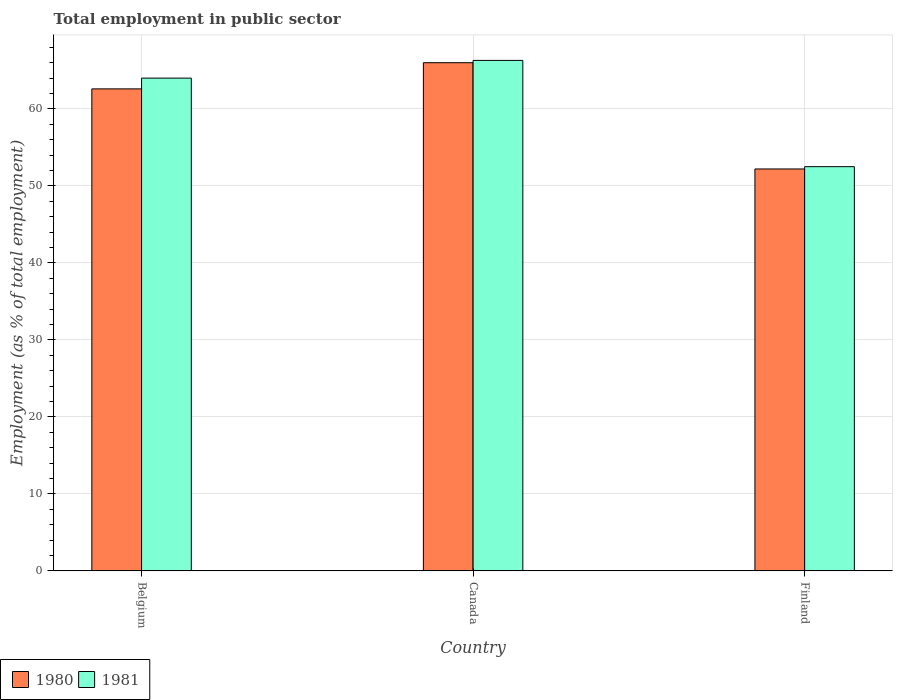Are the number of bars on each tick of the X-axis equal?
Your response must be concise. Yes. What is the label of the 1st group of bars from the left?
Your response must be concise. Belgium. What is the employment in public sector in 1981 in Finland?
Provide a short and direct response. 52.5. Across all countries, what is the minimum employment in public sector in 1980?
Give a very brief answer. 52.2. In which country was the employment in public sector in 1980 maximum?
Keep it short and to the point. Canada. In which country was the employment in public sector in 1981 minimum?
Give a very brief answer. Finland. What is the total employment in public sector in 1981 in the graph?
Ensure brevity in your answer.  182.8. What is the difference between the employment in public sector in 1981 in Belgium and that in Canada?
Keep it short and to the point. -2.3. What is the average employment in public sector in 1980 per country?
Make the answer very short. 60.27. What is the difference between the employment in public sector of/in 1980 and employment in public sector of/in 1981 in Canada?
Ensure brevity in your answer.  -0.3. What is the ratio of the employment in public sector in 1981 in Belgium to that in Canada?
Offer a terse response. 0.97. What is the difference between the highest and the second highest employment in public sector in 1980?
Your response must be concise. 13.8. What is the difference between the highest and the lowest employment in public sector in 1980?
Ensure brevity in your answer.  13.8. What does the 2nd bar from the right in Finland represents?
Provide a short and direct response. 1980. Are the values on the major ticks of Y-axis written in scientific E-notation?
Your response must be concise. No. Does the graph contain any zero values?
Provide a succinct answer. No. Where does the legend appear in the graph?
Your answer should be very brief. Bottom left. How are the legend labels stacked?
Your answer should be compact. Horizontal. What is the title of the graph?
Offer a very short reply. Total employment in public sector. Does "1962" appear as one of the legend labels in the graph?
Provide a short and direct response. No. What is the label or title of the X-axis?
Give a very brief answer. Country. What is the label or title of the Y-axis?
Make the answer very short. Employment (as % of total employment). What is the Employment (as % of total employment) in 1980 in Belgium?
Make the answer very short. 62.6. What is the Employment (as % of total employment) of 1981 in Canada?
Make the answer very short. 66.3. What is the Employment (as % of total employment) of 1980 in Finland?
Make the answer very short. 52.2. What is the Employment (as % of total employment) of 1981 in Finland?
Your answer should be compact. 52.5. Across all countries, what is the maximum Employment (as % of total employment) of 1980?
Offer a terse response. 66. Across all countries, what is the maximum Employment (as % of total employment) of 1981?
Keep it short and to the point. 66.3. Across all countries, what is the minimum Employment (as % of total employment) of 1980?
Your response must be concise. 52.2. Across all countries, what is the minimum Employment (as % of total employment) in 1981?
Make the answer very short. 52.5. What is the total Employment (as % of total employment) in 1980 in the graph?
Provide a succinct answer. 180.8. What is the total Employment (as % of total employment) of 1981 in the graph?
Offer a very short reply. 182.8. What is the difference between the Employment (as % of total employment) in 1980 in Belgium and that in Canada?
Keep it short and to the point. -3.4. What is the difference between the Employment (as % of total employment) in 1981 in Belgium and that in Finland?
Give a very brief answer. 11.5. What is the average Employment (as % of total employment) in 1980 per country?
Provide a short and direct response. 60.27. What is the average Employment (as % of total employment) in 1981 per country?
Your answer should be compact. 60.93. What is the difference between the Employment (as % of total employment) in 1980 and Employment (as % of total employment) in 1981 in Canada?
Offer a very short reply. -0.3. What is the ratio of the Employment (as % of total employment) in 1980 in Belgium to that in Canada?
Provide a short and direct response. 0.95. What is the ratio of the Employment (as % of total employment) in 1981 in Belgium to that in Canada?
Your answer should be compact. 0.97. What is the ratio of the Employment (as % of total employment) in 1980 in Belgium to that in Finland?
Your answer should be compact. 1.2. What is the ratio of the Employment (as % of total employment) in 1981 in Belgium to that in Finland?
Ensure brevity in your answer.  1.22. What is the ratio of the Employment (as % of total employment) in 1980 in Canada to that in Finland?
Offer a terse response. 1.26. What is the ratio of the Employment (as % of total employment) in 1981 in Canada to that in Finland?
Keep it short and to the point. 1.26. What is the difference between the highest and the second highest Employment (as % of total employment) of 1980?
Keep it short and to the point. 3.4. What is the difference between the highest and the second highest Employment (as % of total employment) of 1981?
Your answer should be very brief. 2.3. What is the difference between the highest and the lowest Employment (as % of total employment) in 1980?
Offer a very short reply. 13.8. What is the difference between the highest and the lowest Employment (as % of total employment) of 1981?
Offer a very short reply. 13.8. 